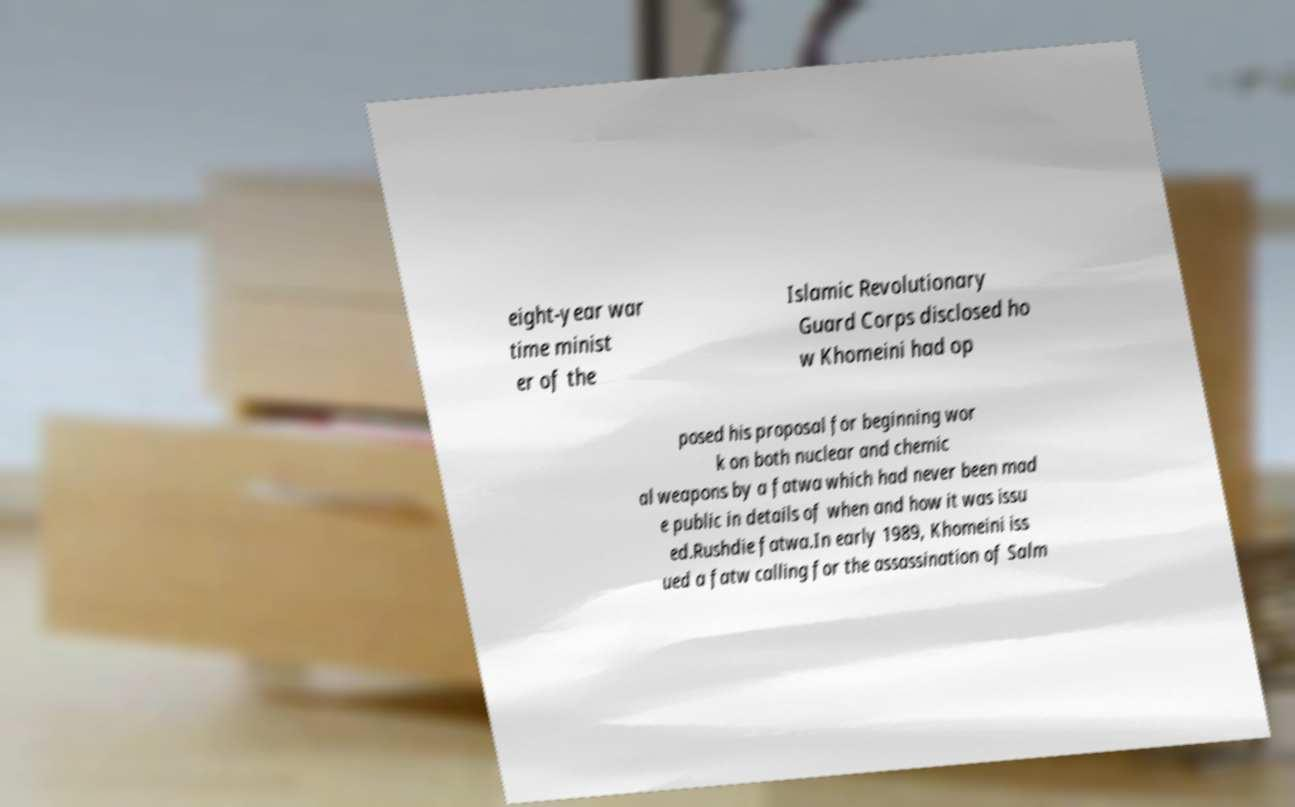Please read and relay the text visible in this image. What does it say? eight-year war time minist er of the Islamic Revolutionary Guard Corps disclosed ho w Khomeini had op posed his proposal for beginning wor k on both nuclear and chemic al weapons by a fatwa which had never been mad e public in details of when and how it was issu ed.Rushdie fatwa.In early 1989, Khomeini iss ued a fatw calling for the assassination of Salm 